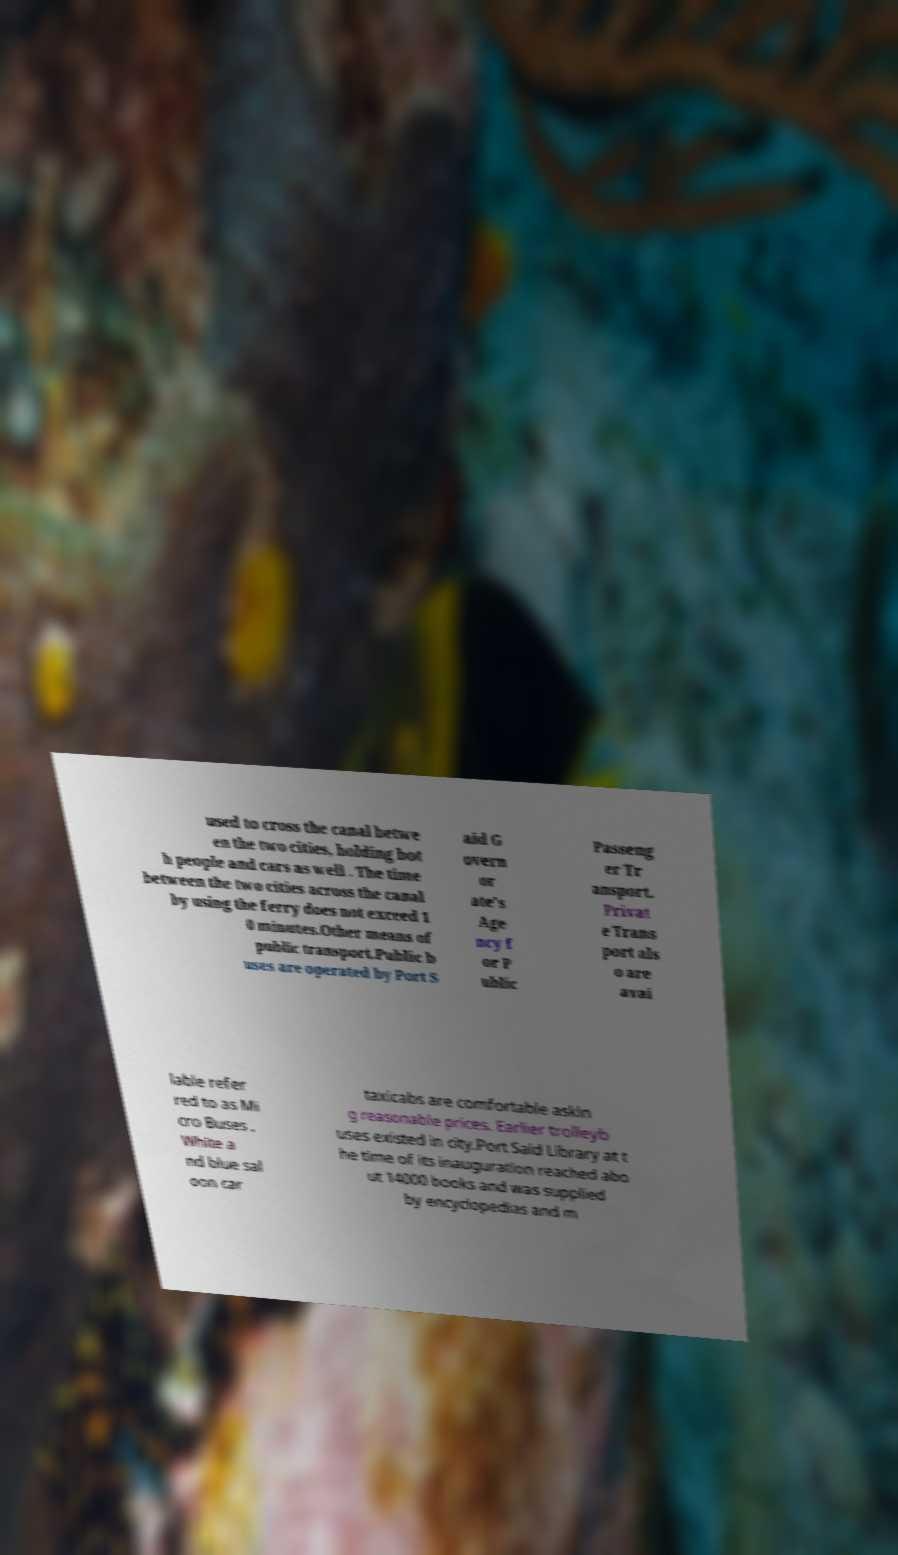Could you extract and type out the text from this image? used to cross the canal betwe en the two cities, holding bot h people and cars as well . The time between the two cities across the canal by using the ferry does not exceed 1 0 minutes.Other means of public transport.Public b uses are operated by Port S aid G overn or ate's Age ncy f or P ublic Passeng er Tr ansport. Privat e Trans port als o are avai lable refer red to as Mi cro Buses . White a nd blue sal oon car taxicabs are comfortable askin g reasonable prices. Earlier trolleyb uses existed in city.Port Said Library at t he time of its inauguration reached abo ut 14000 books and was supplied by encyclopedias and m 